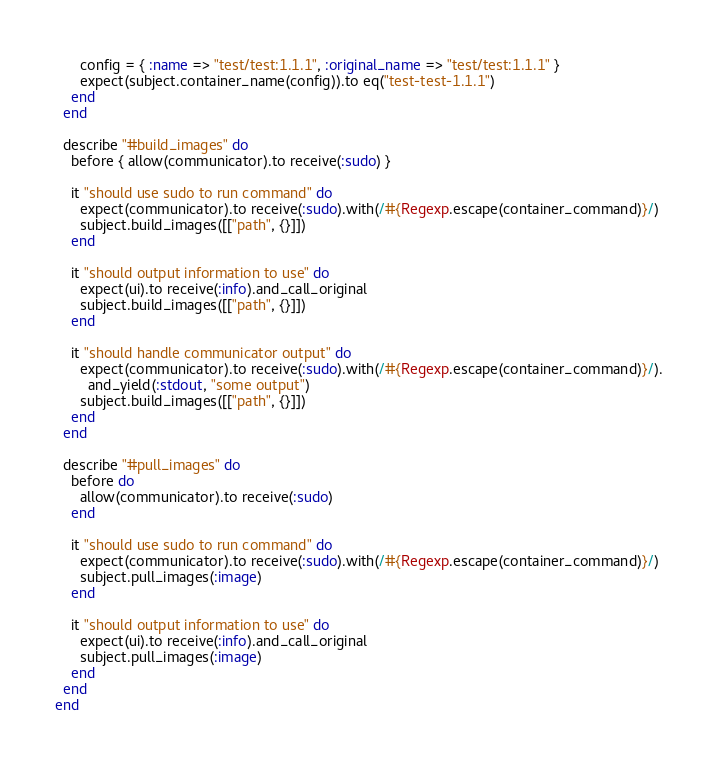<code> <loc_0><loc_0><loc_500><loc_500><_Ruby_>      config = { :name => "test/test:1.1.1", :original_name => "test/test:1.1.1" }
      expect(subject.container_name(config)).to eq("test-test-1.1.1")
    end
  end

  describe "#build_images" do
    before { allow(communicator).to receive(:sudo) }

    it "should use sudo to run command" do
      expect(communicator).to receive(:sudo).with(/#{Regexp.escape(container_command)}/)
      subject.build_images([["path", {}]])
    end

    it "should output information to use" do
      expect(ui).to receive(:info).and_call_original
      subject.build_images([["path", {}]])
    end

    it "should handle communicator output" do
      expect(communicator).to receive(:sudo).with(/#{Regexp.escape(container_command)}/).
        and_yield(:stdout, "some output")
      subject.build_images([["path", {}]])
    end
  end

  describe "#pull_images" do
    before do
      allow(communicator).to receive(:sudo)
    end

    it "should use sudo to run command" do
      expect(communicator).to receive(:sudo).with(/#{Regexp.escape(container_command)}/)
      subject.pull_images(:image)
    end

    it "should output information to use" do
      expect(ui).to receive(:info).and_call_original
      subject.pull_images(:image)
    end
  end
end
</code> 